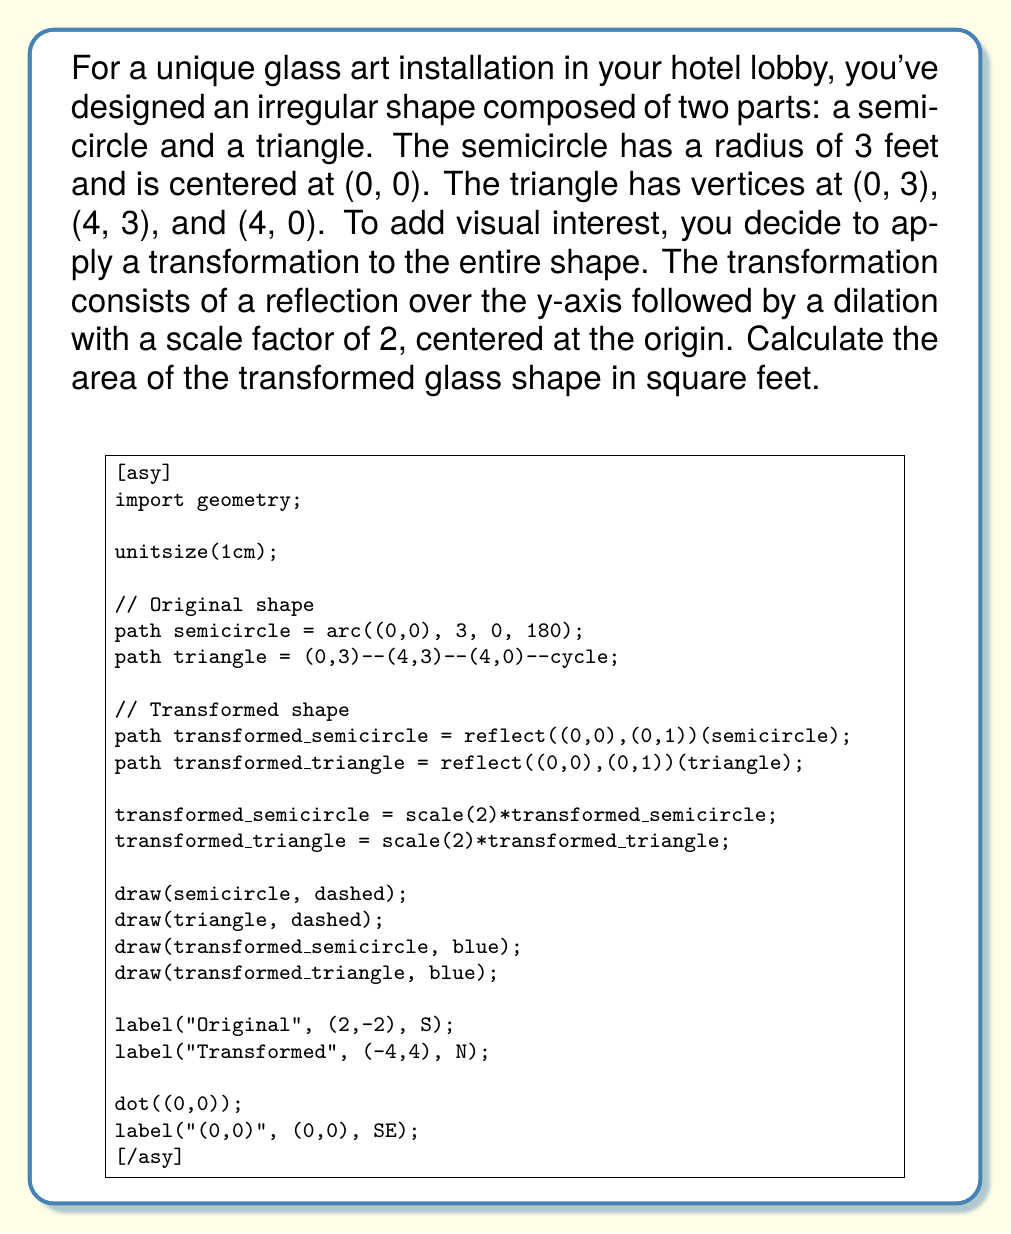Give your solution to this math problem. Let's approach this problem step by step:

1) First, let's calculate the area of the original shape:

   a) Area of the semicircle: 
      $A_s = \frac{1}{2} \pi r^2 = \frac{1}{2} \pi (3^2) = \frac{9\pi}{2}$ sq ft

   b) Area of the triangle:
      $A_t = \frac{1}{2} \text{base} \times \text{height} = \frac{1}{2} \times 4 \times 3 = 6$ sq ft

   c) Total original area: 
      $A_o = A_s + A_t = \frac{9\pi}{2} + 6$ sq ft

2) Now, let's consider the transformations:
   - Reflection over the y-axis doesn't change the area.
   - Dilation with a scale factor of 2 multiplies the area by $2^2 = 4$.

3) Therefore, the area of the transformed shape is:

   $A_t = 4(\frac{9\pi}{2} + 6)$

4) Simplifying:
   $A_t = 18\pi + 24$ sq ft

This is our final answer.
Answer: $18\pi + 24$ square feet 